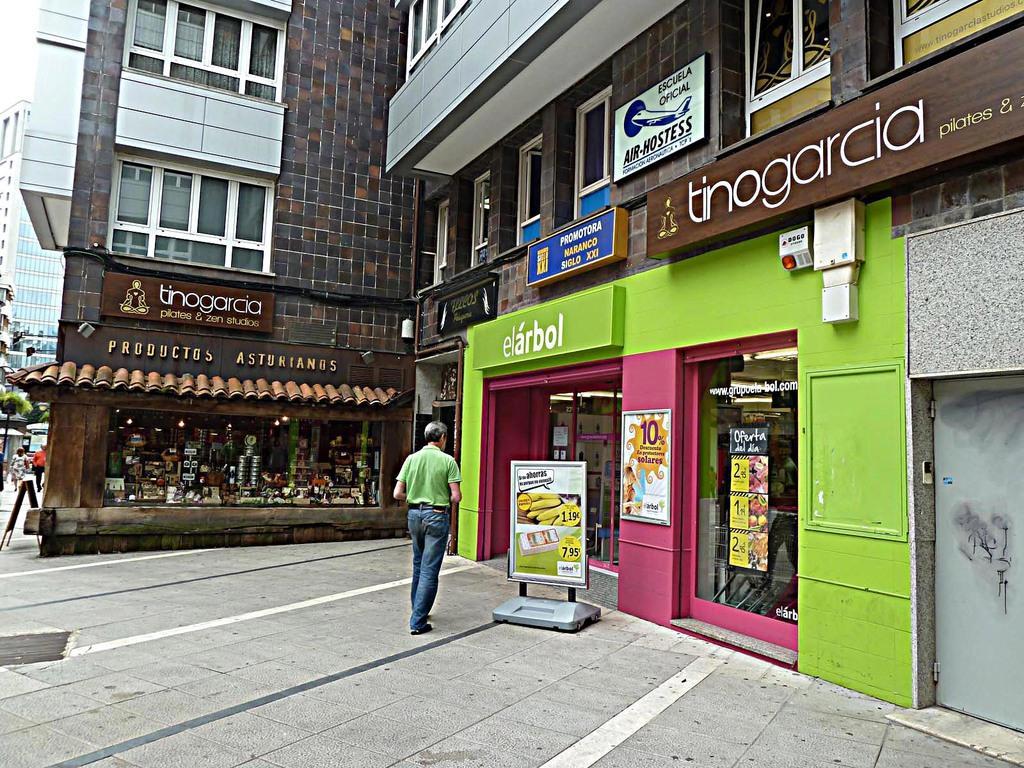Can you describe this image briefly? In the middle of the picture, we see a man in green T-shirt and blue jeans is walking. Beside him, we see a board. In front of him, we see a building in brown and grey color. It has a glass door and it is in green and pink color. On the building we see a green board with some text written on it. On the right side, we see a grey color door. We see a brown color building. We see a brown color board with some text written on it. On the left side, we see two persons are walking. Beside them, we see trees and a building. 